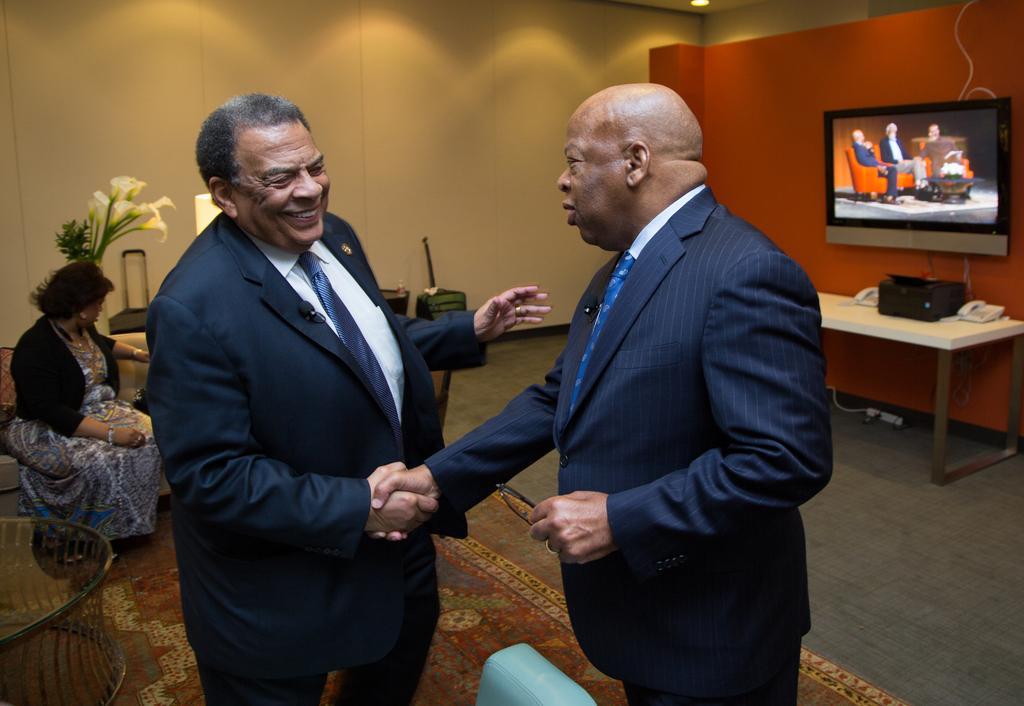Can you describe this image briefly? In this picture I can see two men are shaking their hands and also they are wearing the coats, ties. On the left there is a woman sitting on the sofa, on the right side I can see a television and there are telephones. In the background there is the wall. 